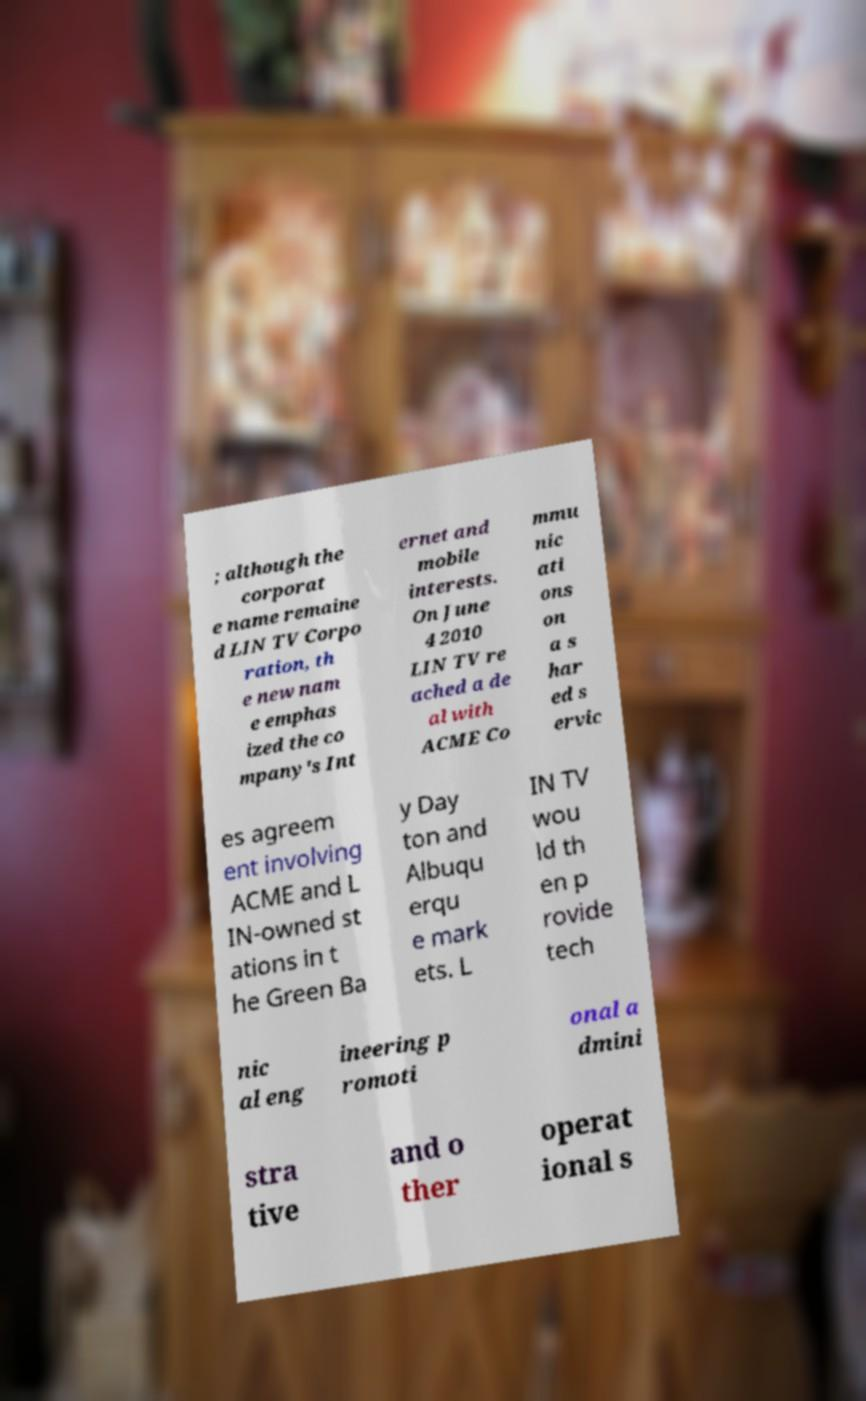Could you assist in decoding the text presented in this image and type it out clearly? ; although the corporat e name remaine d LIN TV Corpo ration, th e new nam e emphas ized the co mpany's Int ernet and mobile interests. On June 4 2010 LIN TV re ached a de al with ACME Co mmu nic ati ons on a s har ed s ervic es agreem ent involving ACME and L IN-owned st ations in t he Green Ba y Day ton and Albuqu erqu e mark ets. L IN TV wou ld th en p rovide tech nic al eng ineering p romoti onal a dmini stra tive and o ther operat ional s 